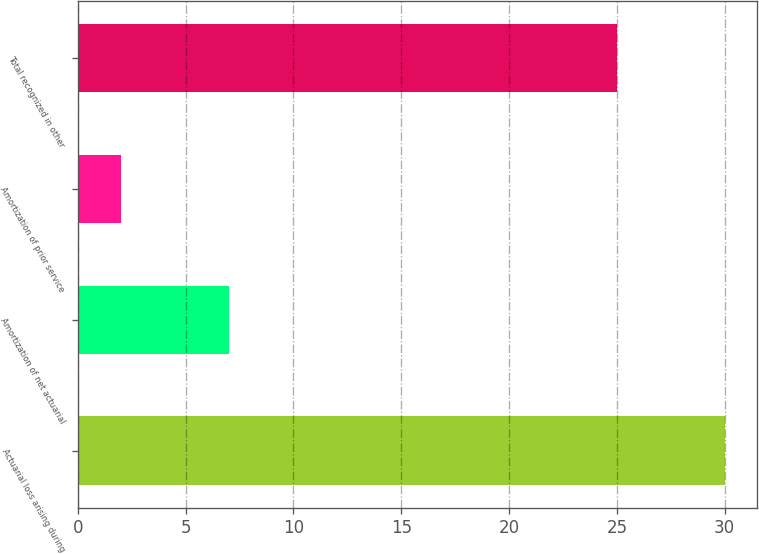Convert chart to OTSL. <chart><loc_0><loc_0><loc_500><loc_500><bar_chart><fcel>Actuarial loss arising during<fcel>Amortization of net actuarial<fcel>Amortization of prior service<fcel>Total recognized in other<nl><fcel>30<fcel>7<fcel>2<fcel>25<nl></chart> 